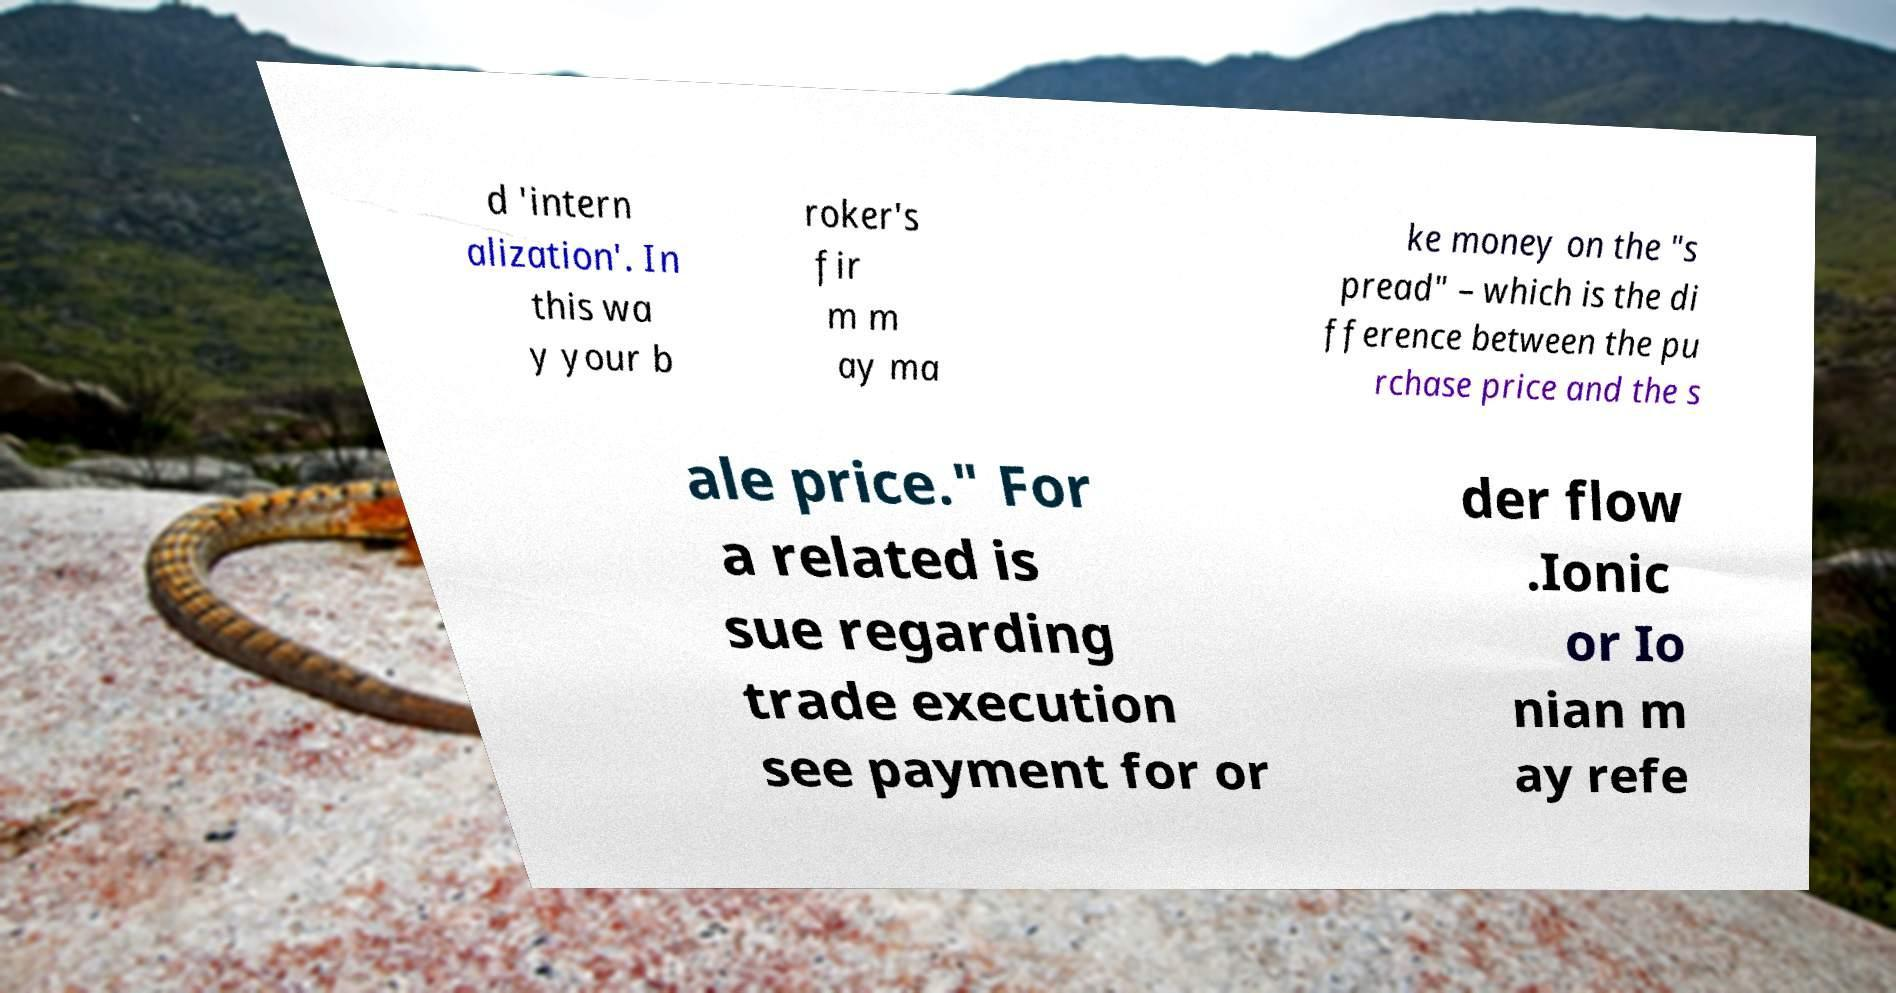For documentation purposes, I need the text within this image transcribed. Could you provide that? d 'intern alization'. In this wa y your b roker's fir m m ay ma ke money on the "s pread" – which is the di fference between the pu rchase price and the s ale price." For a related is sue regarding trade execution see payment for or der flow .Ionic or Io nian m ay refe 